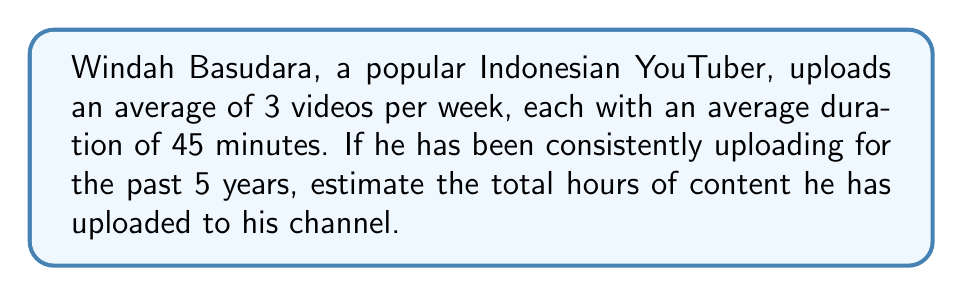What is the answer to this math problem? Let's break this down step-by-step:

1. Calculate the number of weeks in 5 years:
   $$ 5 \text{ years} \times 52 \text{ weeks/year} = 260 \text{ weeks} $$

2. Calculate the total number of videos uploaded:
   $$ 260 \text{ weeks} \times 3 \text{ videos/week} = 780 \text{ videos} $$

3. Convert the average video duration to hours:
   $$ 45 \text{ minutes} = 45 \div 60 = 0.75 \text{ hours} $$

4. Calculate the total hours of content:
   $$ 780 \text{ videos} \times 0.75 \text{ hours/video} = 585 \text{ hours} $$

Therefore, we estimate that Windah Basudara has uploaded approximately 585 hours of content over the past 5 years.
Answer: 585 hours 